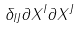Convert formula to latex. <formula><loc_0><loc_0><loc_500><loc_500>\delta _ { I J } \partial X ^ { I } \partial X ^ { J }</formula> 